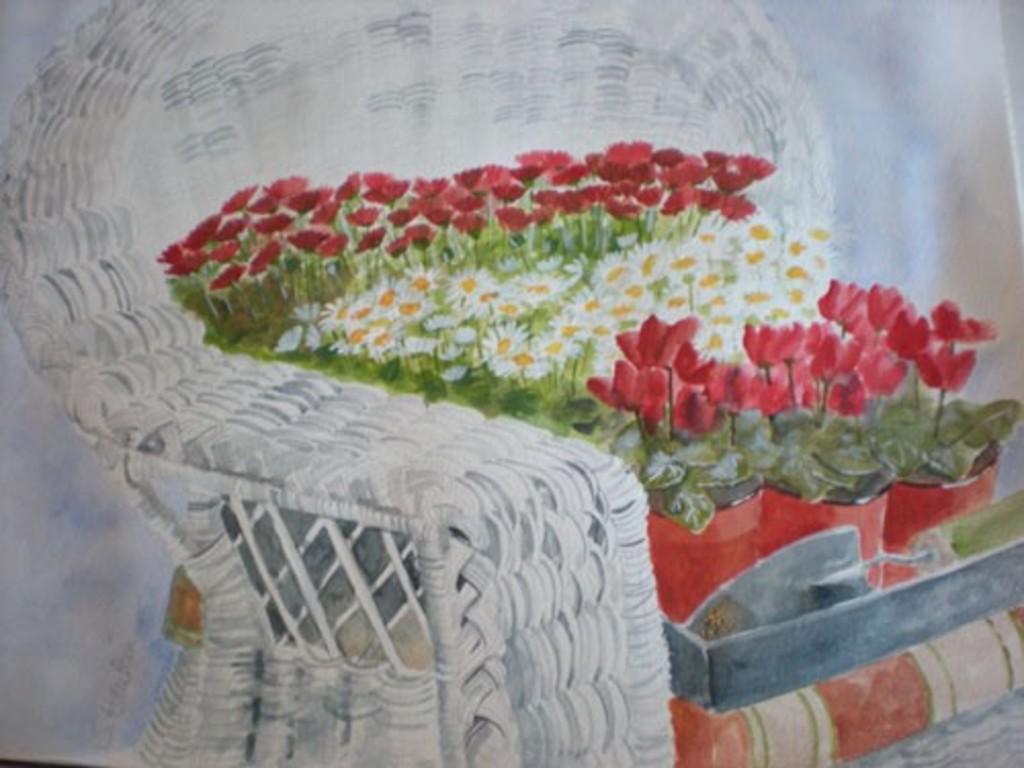What is the main subject of the image? The main subject of the image is a painting. What can be seen in the painting? There is a couch in the painting. Are there any objects on the couch in the painting? Yes, there are flower pots on the couch in the painting. What types of flowers are in the flower pots? The flower pots contain different flowers. Is there any blood visible on the couch in the painting? No, there is no blood visible on the couch in the painting. Can you see a trail of footprints leading to the couch in the painting? No, there is no trail of footprints visible in the painting. 